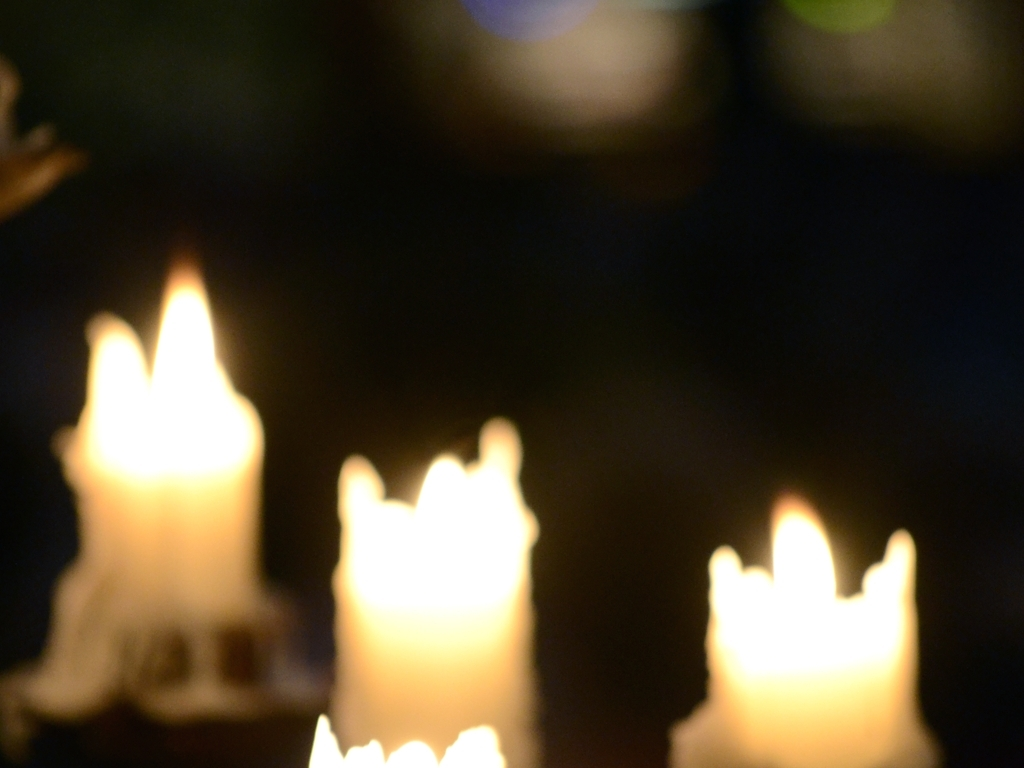What might be the reason for this image to be intentionally out of focus? The intentional blurriness could be to create a particular mood or atmosphere, particularly one of warmth and intimacy. Alternatively, it could be a creative choice to focus on the abstract shapes and colors rather than the details of the candles. 